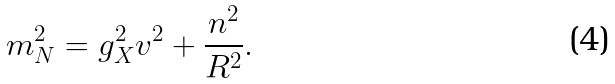<formula> <loc_0><loc_0><loc_500><loc_500>m ^ { 2 } _ { N } = g ^ { 2 } _ { X } v ^ { 2 } + \frac { n ^ { 2 } } { R ^ { 2 } } .</formula> 